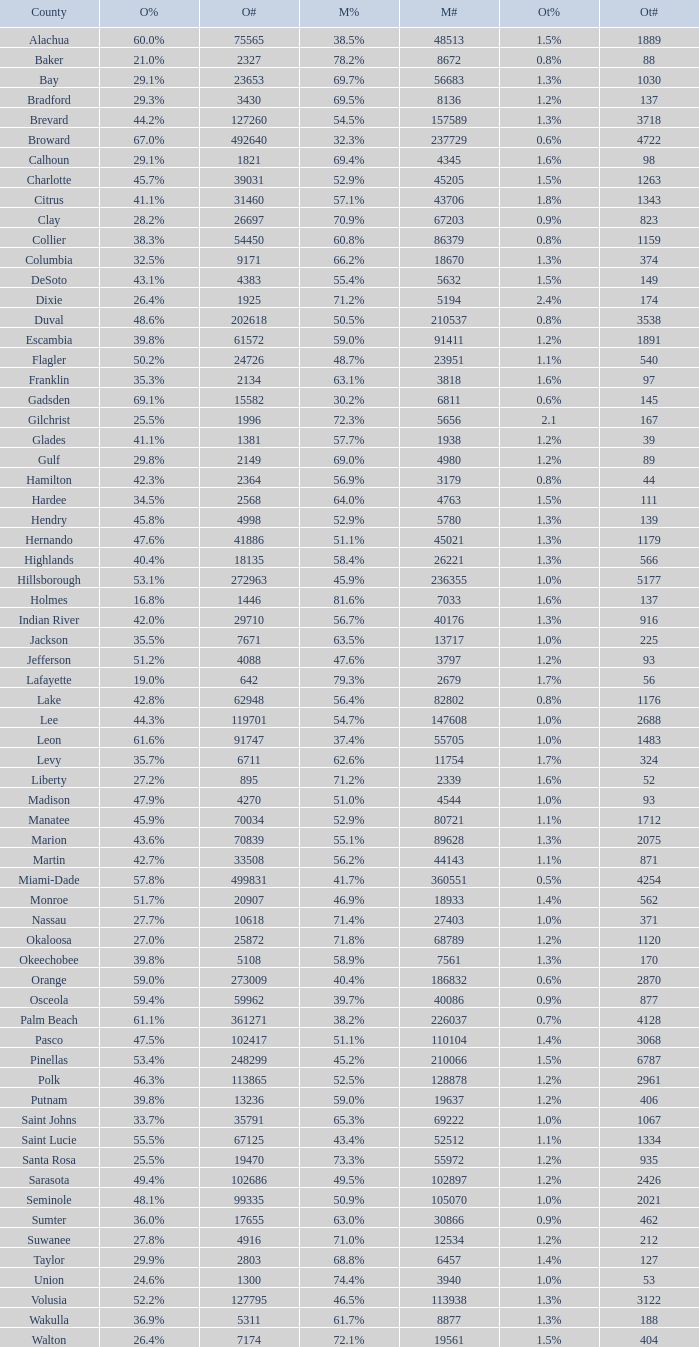What was the count of mccain's voters when 895 people voted for obama? 2339.0. 